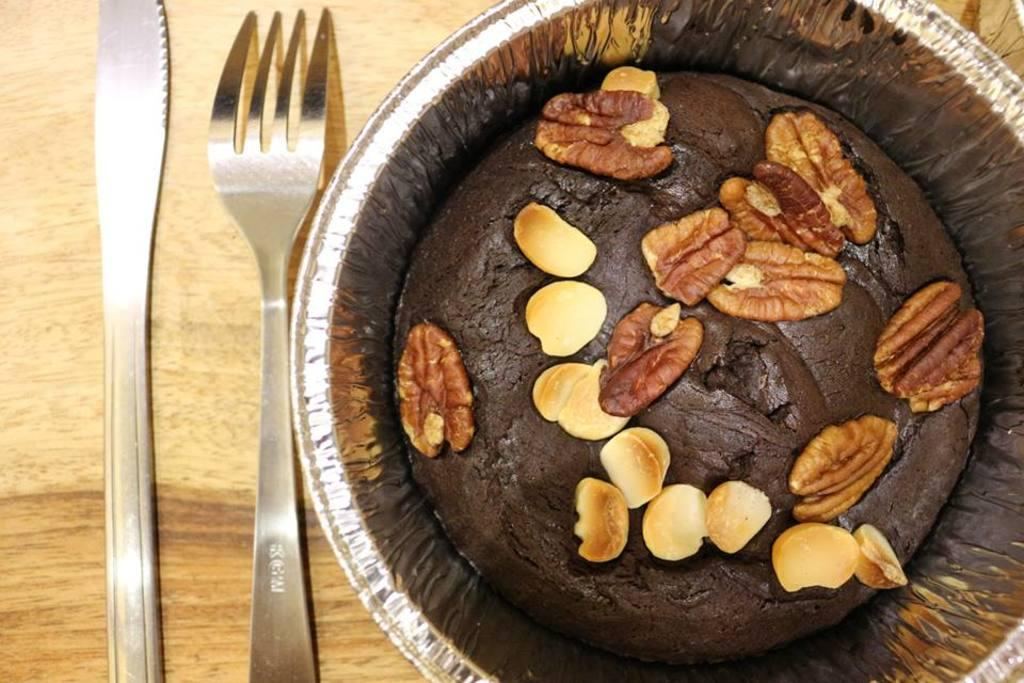What is the main object in the foreground of the image? There is an object that resembles a cake in a cup in the foreground of the image. On which side of the image is the cake-like object located? The object is on the right side of the image. What utensils are present in the foreground of the image? There is a knife and a fork in the foreground of the image. Where are the knife and fork placed in the image? The knife and fork are on a wooden surface on the left side of the image. What type of crib can be seen in the image? There is no crib present in the image. What type of scissors is the judge using in the image? There is no judge or scissors present in the image. 